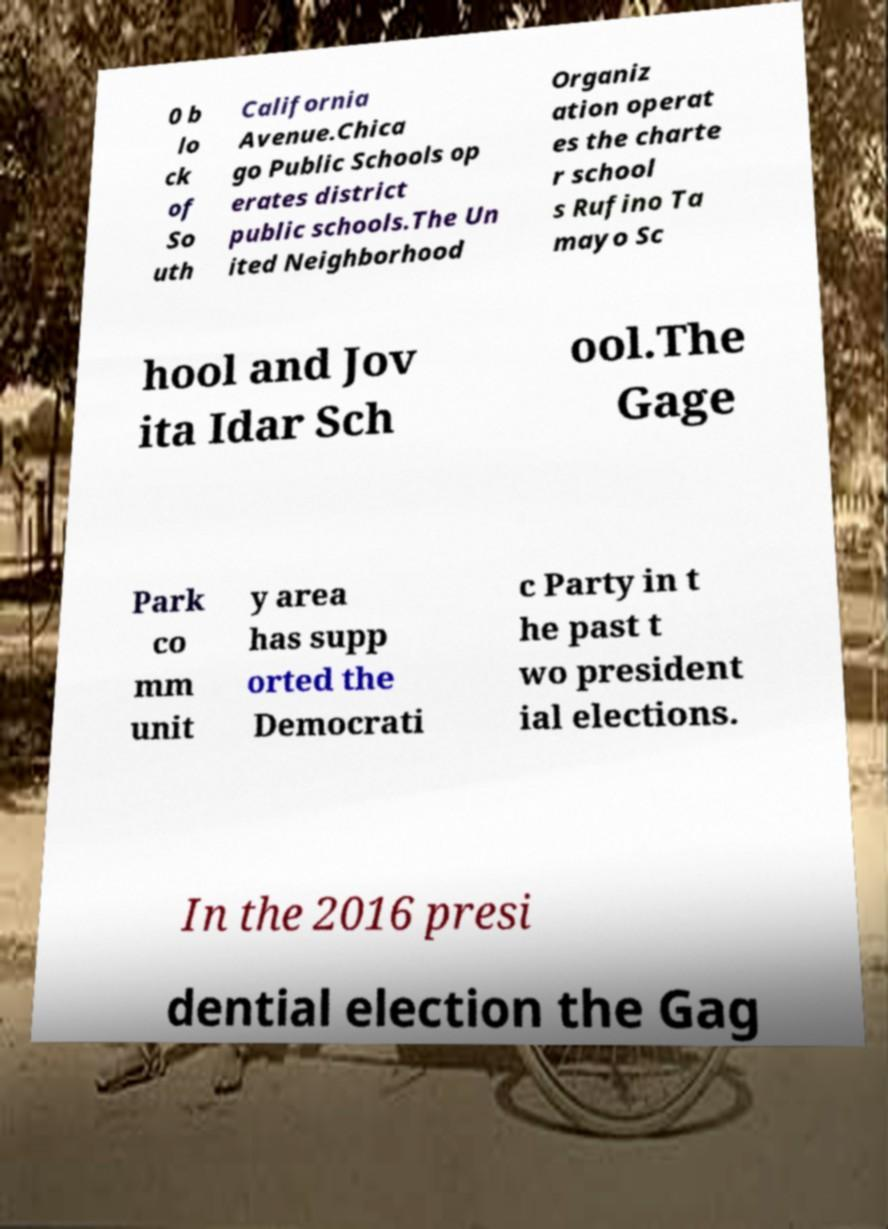Can you accurately transcribe the text from the provided image for me? 0 b lo ck of So uth California Avenue.Chica go Public Schools op erates district public schools.The Un ited Neighborhood Organiz ation operat es the charte r school s Rufino Ta mayo Sc hool and Jov ita Idar Sch ool.The Gage Park co mm unit y area has supp orted the Democrati c Party in t he past t wo president ial elections. In the 2016 presi dential election the Gag 